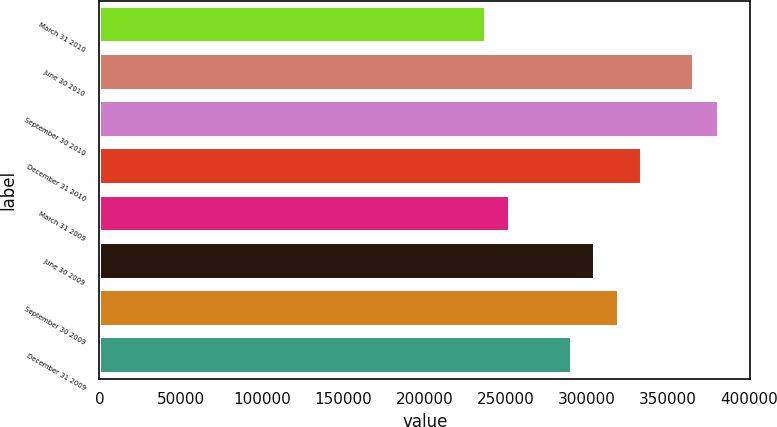<chart> <loc_0><loc_0><loc_500><loc_500><bar_chart><fcel>March 31 2010<fcel>June 30 2010<fcel>September 30 2010<fcel>December 31 2010<fcel>March 31 2009<fcel>June 30 2009<fcel>September 30 2009<fcel>December 31 2009<nl><fcel>238110<fcel>365701<fcel>381466<fcel>333921<fcel>252446<fcel>305250<fcel>319585<fcel>290914<nl></chart> 